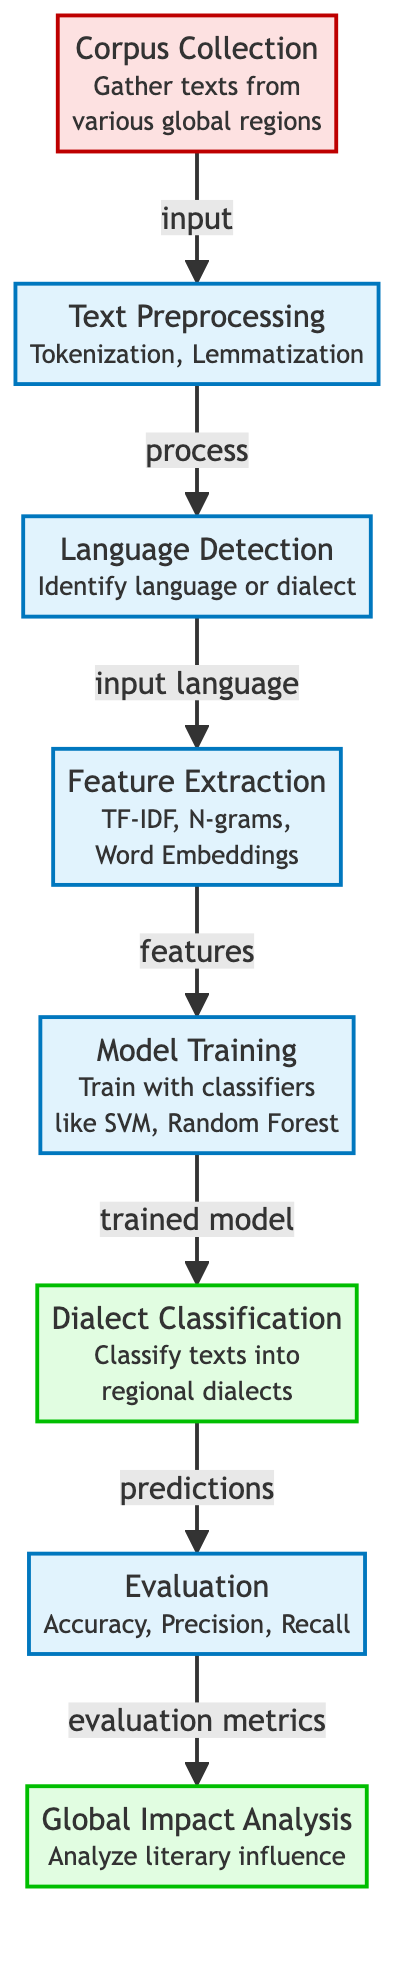What is the first step in the classification process? The first step in the process is "Corpus Collection," where texts are gathered from various global regions. This is explicitly stated in the diagram.
Answer: Corpus Collection How many total stages are there in the diagram? The diagram includes a total of eight stages, which can be counted from the nodes represented in the flowchart.
Answer: Eight What is the immediate output of the "Model Training" step? The immediate output of the "Model Training" step is a trained model, which is used for dialect classification. This is indicated by the directional flow from the "Model Training" node to the "Dialect Classification" node.
Answer: Trained model What type of metrics are used in the "Evaluation" step? The evaluation step employs accuracy, precision, and recall as metrics. This information is specified beneath the "Evaluation" node in the diagram.
Answer: Accuracy, Precision, Recall Which step follows "Dialect Classification"? The step that follows "Dialect Classification" is "Evaluation." This is shown by the directed arrow linking these two steps in the flowchart.
Answer: Evaluation What forms of feature extraction methods are mentioned? The forms of feature extraction methods mentioned include TF-IDF, N-grams, and word embeddings, explicitly listed in the "Feature Extraction" node.
Answer: TF-IDF, N-grams, Word Embeddings What is the final output of the process? The final output of the process is "Global Impact Analysis," which is the last node in the flow. This indicates the outcome of the preceding steps related to dialect classification.
Answer: Global Impact Analysis How is language detected in this process? Language is detected through the "Language Detection" step, which identifies the language or dialect of the texts before feature extraction begins. The diagram connects these steps to show the flow of information.
Answer: Identify language or dialect What is the role of Text Preprocessing? The role of "Text Preprocessing" is to prepare the texts through tokenization and lemmatization. This preparation is crucial for subsequent steps and is explicitly noted in the diagram.
Answer: Tokenization, Lemmatization 